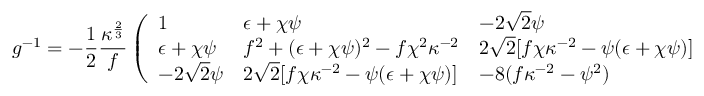<formula> <loc_0><loc_0><loc_500><loc_500>g ^ { - 1 } = - { \frac { 1 } { 2 } } { \frac { \kappa ^ { \frac { 2 } { 3 } } } { f } } \left ( \begin{array} { l l l } { 1 } & { \epsilon + \chi \psi } & { - 2 \sqrt { 2 } \psi } \\ { \epsilon + \chi \psi } & { { f ^ { 2 } + ( \epsilon + \chi \psi ) ^ { 2 } - f \chi ^ { 2 } \kappa ^ { - 2 } } } & { { 2 \sqrt { 2 } [ f \chi \kappa ^ { - 2 } - \psi ( \epsilon + \chi \psi ) ] } } \\ { - 2 \sqrt { 2 } \psi } & { { 2 \sqrt { 2 } [ f \chi \kappa ^ { - 2 } - \psi ( \epsilon + \chi \psi ) ] } } & { { - 8 ( f \kappa ^ { - 2 } - \psi ^ { 2 } ) } } \end{array} \right ) ,</formula> 